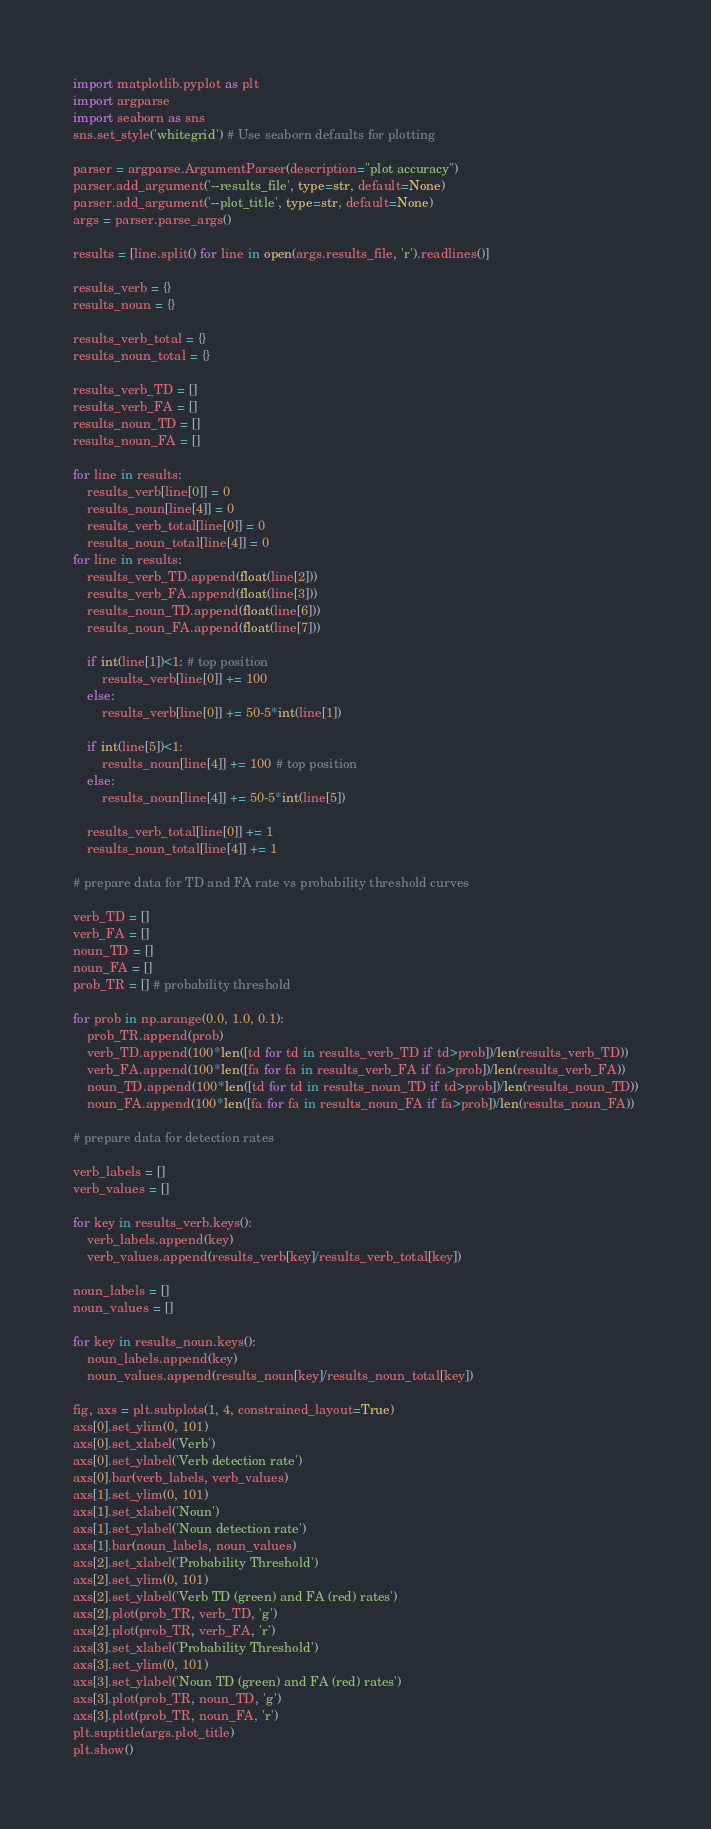<code> <loc_0><loc_0><loc_500><loc_500><_Python_>import matplotlib.pyplot as plt
import argparse
import seaborn as sns
sns.set_style('whitegrid') # Use seaborn defaults for plotting

parser = argparse.ArgumentParser(description="plot accuracy")
parser.add_argument('--results_file', type=str, default=None)
parser.add_argument('--plot_title', type=str, default=None)
args = parser.parse_args()

results = [line.split() for line in open(args.results_file, 'r').readlines()]

results_verb = {} 
results_noun = {} 

results_verb_total = {}
results_noun_total = {}

results_verb_TD = [] 
results_verb_FA = []
results_noun_TD = [] 
results_noun_FA = []

for line in results:
    results_verb[line[0]] = 0
    results_noun[line[4]] = 0
    results_verb_total[line[0]] = 0
    results_noun_total[line[4]] = 0
for line in results:
    results_verb_TD.append(float(line[2]))
    results_verb_FA.append(float(line[3]))
    results_noun_TD.append(float(line[6]))
    results_noun_FA.append(float(line[7]))

    if int(line[1])<1: # top position
        results_verb[line[0]] += 100        
    else: 
        results_verb[line[0]] += 50-5*int(line[1])

    if int(line[5])<1: 
        results_noun[line[4]] += 100 # top position
    else:
        results_noun[line[4]] += 50-5*int(line[5])

    results_verb_total[line[0]] += 1
    results_noun_total[line[4]] += 1

# prepare data for TD and FA rate vs probability threshold curves 

verb_TD = []
verb_FA = []
noun_TD = []
noun_FA = []
prob_TR = [] # probability threshold

for prob in np.arange(0.0, 1.0, 0.1):
    prob_TR.append(prob)
    verb_TD.append(100*len([td for td in results_verb_TD if td>prob])/len(results_verb_TD))
    verb_FA.append(100*len([fa for fa in results_verb_FA if fa>prob])/len(results_verb_FA))
    noun_TD.append(100*len([td for td in results_noun_TD if td>prob])/len(results_noun_TD))
    noun_FA.append(100*len([fa for fa in results_noun_FA if fa>prob])/len(results_noun_FA))

# prepare data for detection rates

verb_labels = []
verb_values = []

for key in results_verb.keys():
    verb_labels.append(key)
    verb_values.append(results_verb[key]/results_verb_total[key])

noun_labels = []
noun_values = []

for key in results_noun.keys():
    noun_labels.append(key)
    noun_values.append(results_noun[key]/results_noun_total[key])

fig, axs = plt.subplots(1, 4, constrained_layout=True)
axs[0].set_ylim(0, 101)
axs[0].set_xlabel('Verb')
axs[0].set_ylabel('Verb detection rate')
axs[0].bar(verb_labels, verb_values)
axs[1].set_ylim(0, 101)
axs[1].set_xlabel('Noun')
axs[1].set_ylabel('Noun detection rate')
axs[1].bar(noun_labels, noun_values)
axs[2].set_xlabel('Probability Threshold')
axs[2].set_ylim(0, 101)
axs[2].set_ylabel('Verb TD (green) and FA (red) rates')
axs[2].plot(prob_TR, verb_TD, 'g')
axs[2].plot(prob_TR, verb_FA, 'r')
axs[3].set_xlabel('Probability Threshold')
axs[3].set_ylim(0, 101)
axs[3].set_ylabel('Noun TD (green) and FA (red) rates')
axs[3].plot(prob_TR, noun_TD, 'g')
axs[3].plot(prob_TR, noun_FA, 'r')
plt.suptitle(args.plot_title)
plt.show()

</code> 